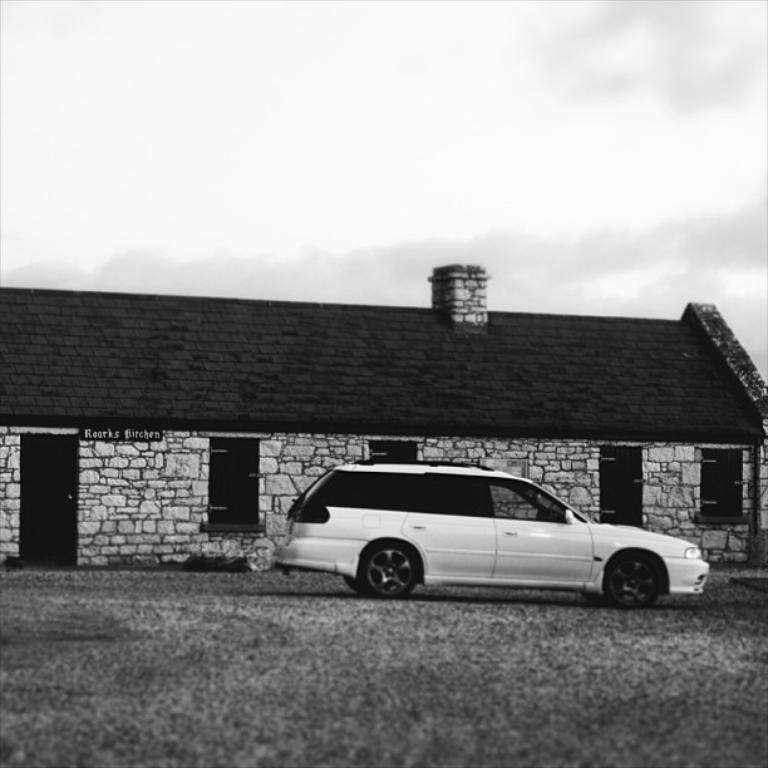What is the color scheme of the image? The image is black and white. What type of house can be seen in the image? There is a house made up of rocks in the image. What is parked in the center of the image? A car is parked in the center of the image. Where is the car located in relation to the ground? The car is on the ground. What is visible at the top of the image? The sky is visible at the top of the image. What type of haircut does the border have in the image? There is no border or haircut present in the image. How is the scale of the house compared to the car in the image? The provided facts do not give information about the scale of the house compared to the car, so it cannot be determined from the image. 